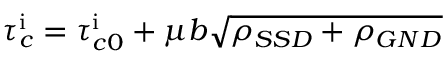Convert formula to latex. <formula><loc_0><loc_0><loc_500><loc_500>\tau _ { c } ^ { i } = \tau _ { c 0 } ^ { i } + \mu b \sqrt { \rho _ { S S D } + \rho _ { G N D } }</formula> 